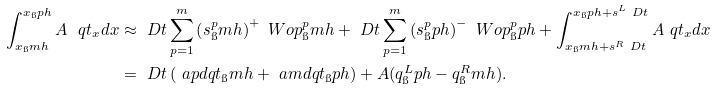<formula> <loc_0><loc_0><loc_500><loc_500>\int _ { x _ { \i } m h } ^ { x _ { \i } p h } A \ q t _ { x } d x & \approx \ D t \sum _ { p = 1 } ^ { m } \left ( s ^ { p } _ { \i } m h \right ) ^ { + } \ W o p ^ { p } _ { \i } m h + \ D t \sum _ { p = 1 } ^ { m } \left ( s ^ { p } _ { \i } p h \right ) ^ { - } \ W o p ^ { p } _ { \i } p h + \int _ { x _ { \i } m h + s ^ { R } \ D t } ^ { x _ { \i } p h + s ^ { L } \ D t } A \ q t _ { x } d x \\ & = \ D t \left ( \ a p d q t _ { \i } m h + \ a m d q t _ { \i } p h \right ) + A ( q ^ { L } _ { \i } p h - q ^ { R } _ { \i } m h ) .</formula> 